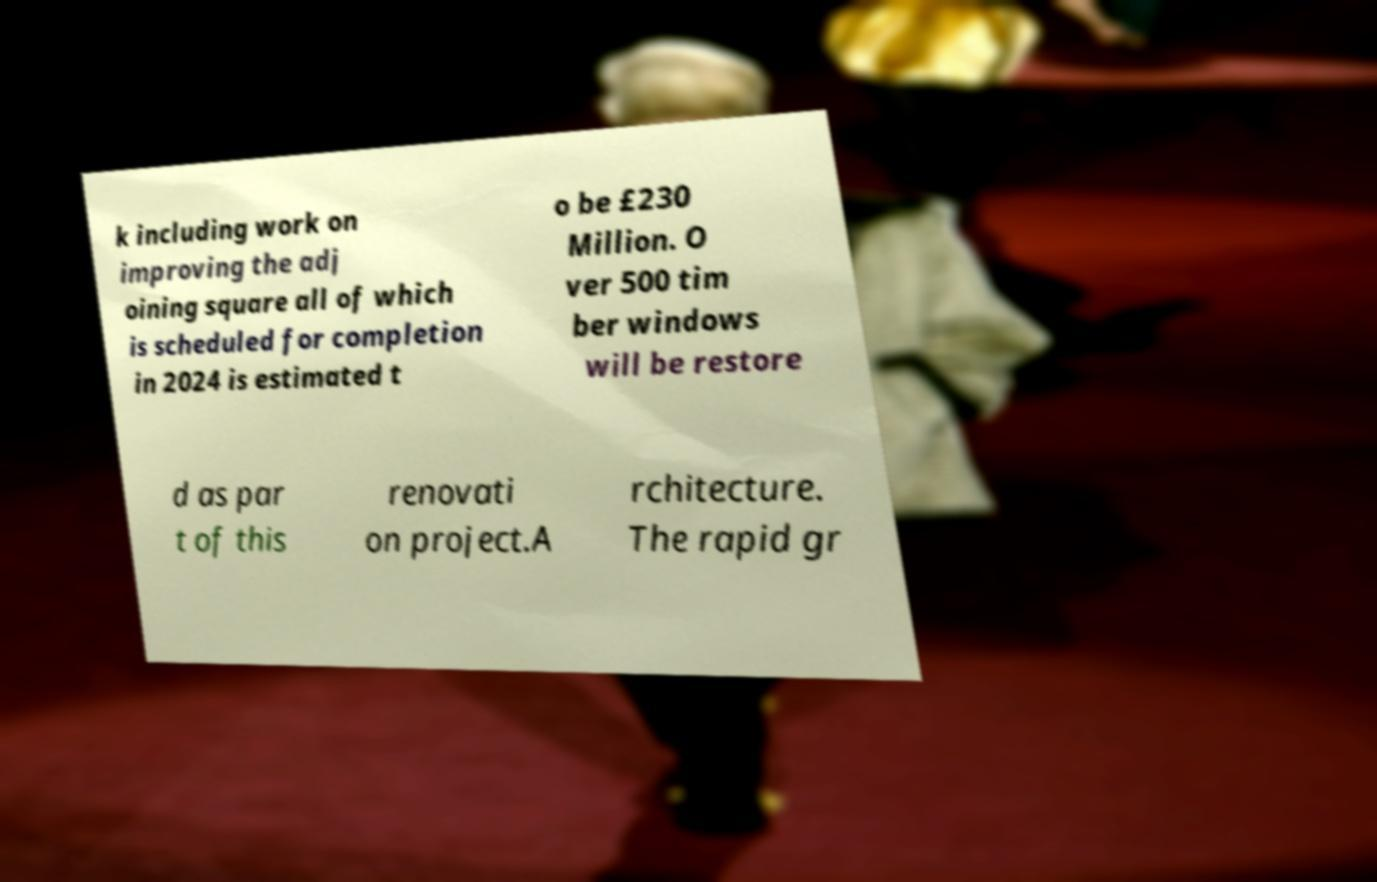Could you assist in decoding the text presented in this image and type it out clearly? k including work on improving the adj oining square all of which is scheduled for completion in 2024 is estimated t o be £230 Million. O ver 500 tim ber windows will be restore d as par t of this renovati on project.A rchitecture. The rapid gr 